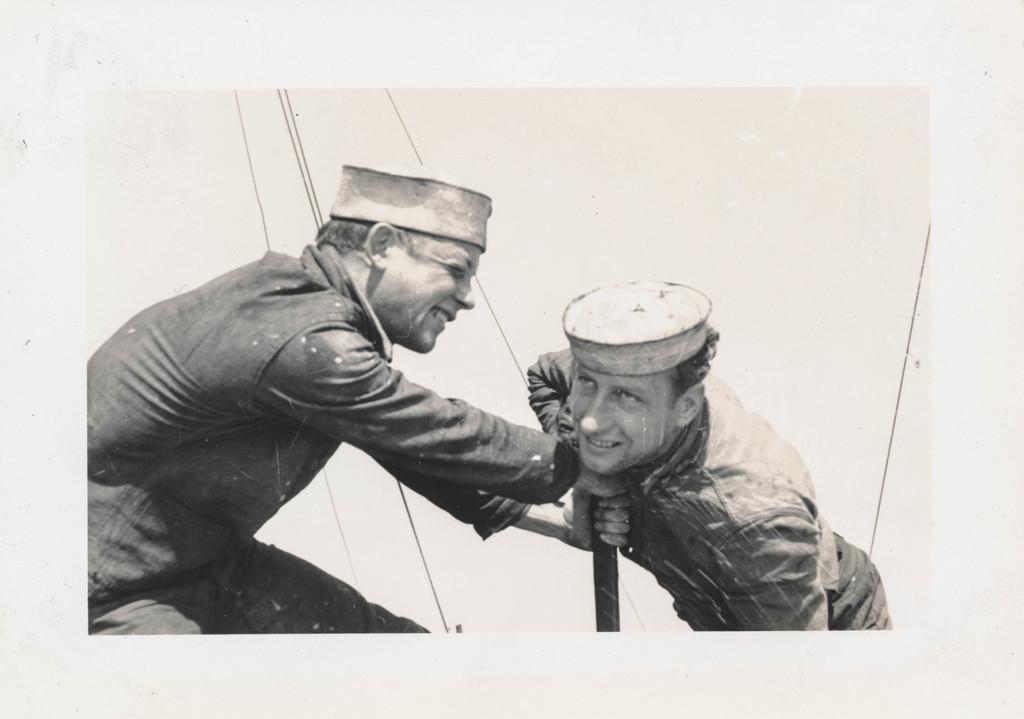Can you describe this image briefly? This is an old black and white image. I can see two men standing. They wore caps and shirts. This looks like a pole. I think these are the ropes. 